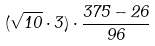Convert formula to latex. <formula><loc_0><loc_0><loc_500><loc_500>( \sqrt { 1 0 } \cdot 3 ) \cdot \frac { 3 7 5 - 2 6 } { 9 6 }</formula> 